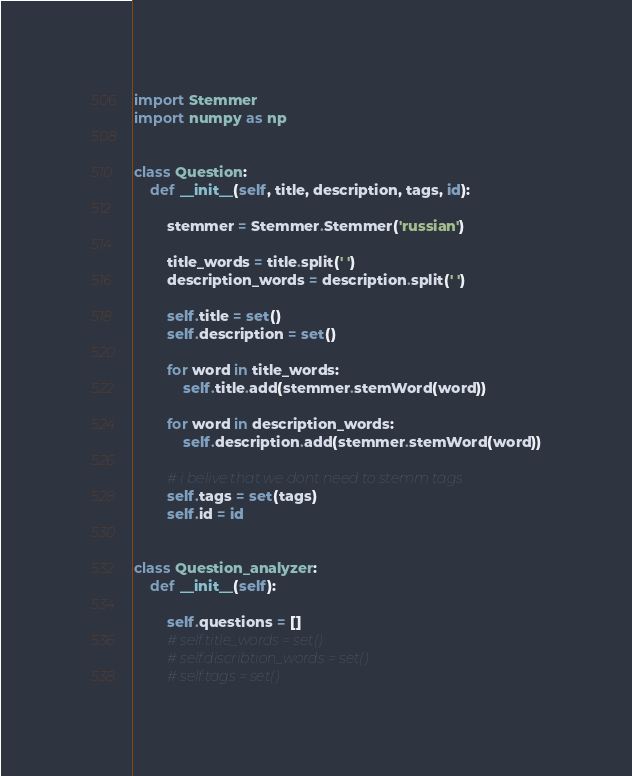<code> <loc_0><loc_0><loc_500><loc_500><_Python_>import Stemmer
import numpy as np


class Question:
    def __init__(self, title, description, tags, id):

        stemmer = Stemmer.Stemmer('russian')

        title_words = title.split(' ')
        description_words = description.split(' ')

        self.title = set()
        self.description = set()

        for word in title_words:
            self.title.add(stemmer.stemWord(word))

        for word in description_words:
            self.description.add(stemmer.stemWord(word))

        # i belive that we dont need to stemm tags
        self.tags = set(tags)
        self.id = id


class Question_analyzer:
    def __init__(self):

        self.questions = []
        # self.title_words = set()
        # self.discribtion_words = set()
        # self.tags = set()
</code> 